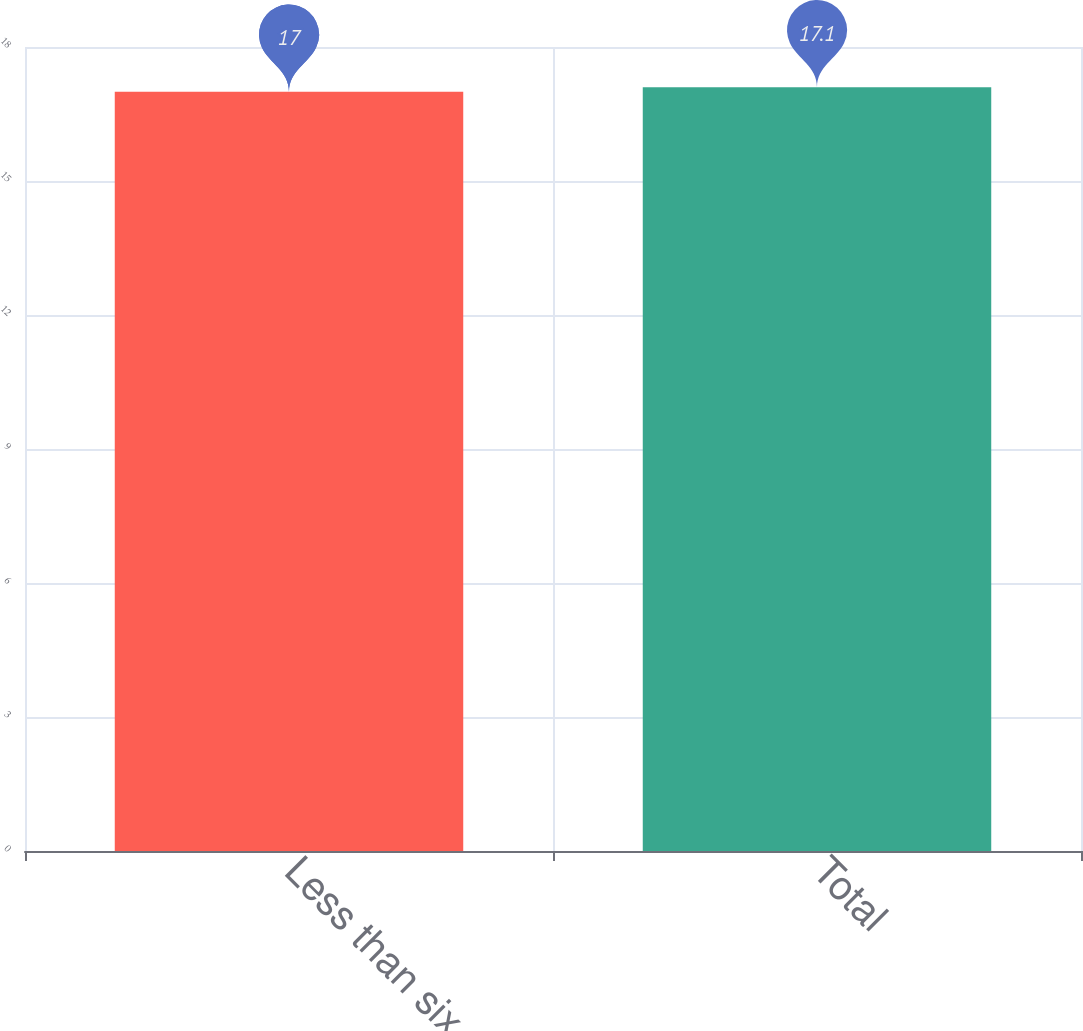Convert chart. <chart><loc_0><loc_0><loc_500><loc_500><bar_chart><fcel>Less than six months<fcel>Total<nl><fcel>17<fcel>17.1<nl></chart> 